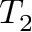<formula> <loc_0><loc_0><loc_500><loc_500>T _ { 2 }</formula> 